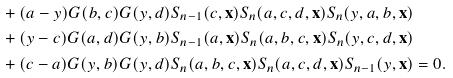<formula> <loc_0><loc_0><loc_500><loc_500>& + ( a - y ) G ( b , c ) G ( y , d ) S _ { n - 1 } ( c , \mathbf x ) S _ { n } ( a , c , d , \mathbf x ) S _ { n } ( y , a , b , \mathbf x ) \\ & + ( y - c ) G ( a , d ) G ( y , b ) S _ { n - 1 } ( a , \mathbf x ) S _ { n } ( a , b , c , \mathbf x ) S _ { n } ( y , c , d , \mathbf x ) \\ & + ( c - a ) G ( y , b ) G ( y , d ) S _ { n } ( a , b , c , \mathbf x ) S _ { n } ( a , c , d , \mathbf x ) S _ { n - 1 } ( y , \mathbf x ) = 0 .</formula> 